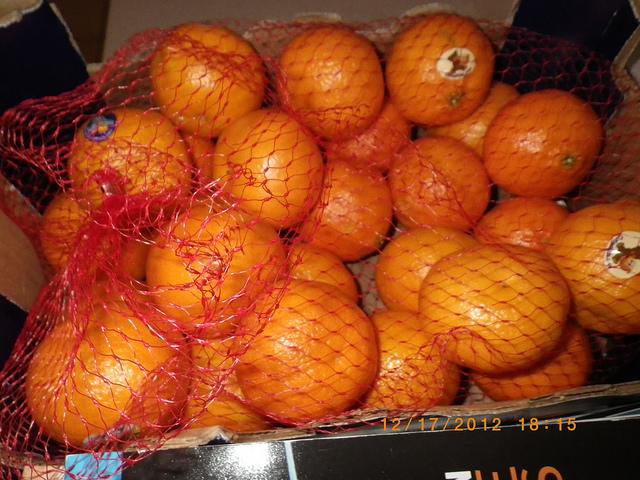How many pieces of fruit has stickers on them?
Keep it brief. 3. What kind of fruit is this?
Concise answer only. Orange. How many oranges are in the bag?
Write a very short answer. 23. What is in the bag?
Quick response, please. Oranges. Are raisins in this photo?
Write a very short answer. No. What is bagged up?
Answer briefly. Oranges. Have any oranges already been sliced?
Be succinct. No. Which item is a fruit?
Keep it brief. Orange. Are the circular things called scallops?
Give a very brief answer. No. In what city was this fruit picked?
Write a very short answer. Zuko. What type of fruit is this?
Answer briefly. Orange. When was this picture taken?
Answer briefly. 12/17/2012. 